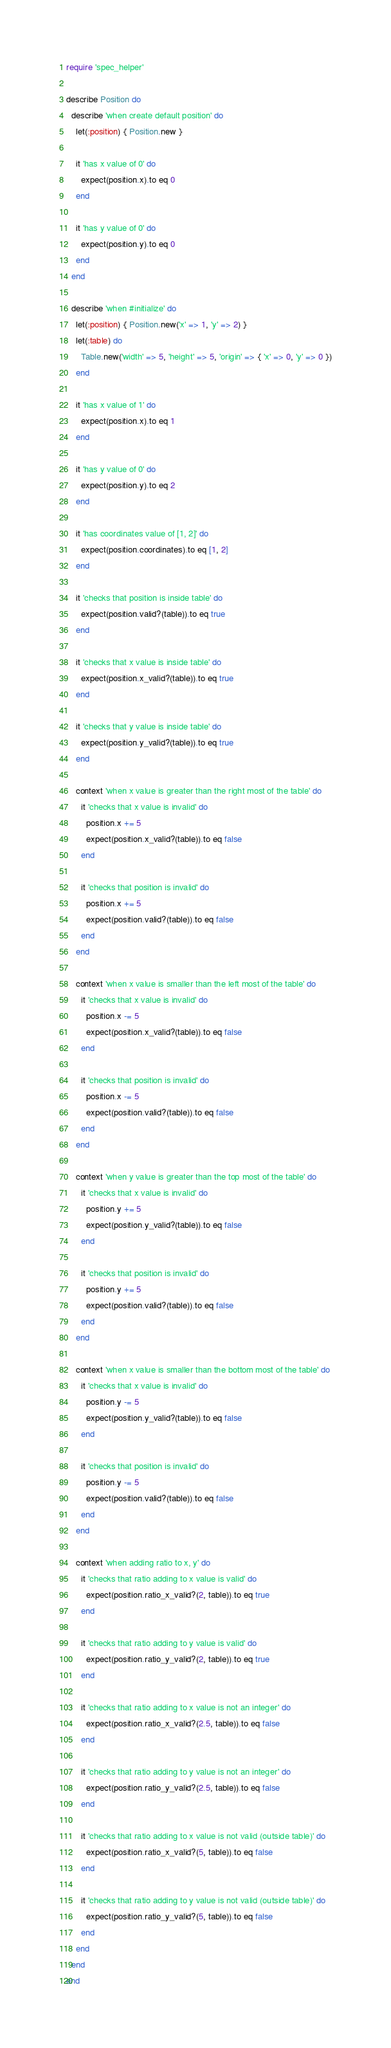<code> <loc_0><loc_0><loc_500><loc_500><_Ruby_>require 'spec_helper'

describe Position do
  describe 'when create default position' do
    let(:position) { Position.new }

    it 'has x value of 0' do
      expect(position.x).to eq 0
    end

    it 'has y value of 0' do
      expect(position.y).to eq 0
    end
  end

  describe 'when #initialize' do
    let(:position) { Position.new('x' => 1, 'y' => 2) }
    let(:table) do
      Table.new('width' => 5, 'height' => 5, 'origin' => { 'x' => 0, 'y' => 0 })
    end

    it 'has x value of 1' do
      expect(position.x).to eq 1
    end

    it 'has y value of 0' do
      expect(position.y).to eq 2
    end

    it 'has coordinates value of [1, 2]' do
      expect(position.coordinates).to eq [1, 2]
    end

    it 'checks that position is inside table' do
      expect(position.valid?(table)).to eq true
    end

    it 'checks that x value is inside table' do
      expect(position.x_valid?(table)).to eq true
    end

    it 'checks that y value is inside table' do
      expect(position.y_valid?(table)).to eq true
    end

    context 'when x value is greater than the right most of the table' do
      it 'checks that x value is invalid' do
        position.x += 5
        expect(position.x_valid?(table)).to eq false
      end

      it 'checks that position is invalid' do
        position.x += 5
        expect(position.valid?(table)).to eq false
      end
    end

    context 'when x value is smaller than the left most of the table' do
      it 'checks that x value is invalid' do
        position.x -= 5
        expect(position.x_valid?(table)).to eq false
      end

      it 'checks that position is invalid' do
        position.x -= 5
        expect(position.valid?(table)).to eq false
      end
    end

    context 'when y value is greater than the top most of the table' do
      it 'checks that x value is invalid' do
        position.y += 5
        expect(position.y_valid?(table)).to eq false
      end

      it 'checks that position is invalid' do
        position.y += 5
        expect(position.valid?(table)).to eq false
      end
    end

    context 'when x value is smaller than the bottom most of the table' do
      it 'checks that x value is invalid' do
        position.y -= 5
        expect(position.y_valid?(table)).to eq false
      end

      it 'checks that position is invalid' do
        position.y -= 5
        expect(position.valid?(table)).to eq false
      end
    end

    context 'when adding ratio to x, y' do
      it 'checks that ratio adding to x value is valid' do
        expect(position.ratio_x_valid?(2, table)).to eq true
      end

      it 'checks that ratio adding to y value is valid' do
        expect(position.ratio_y_valid?(2, table)).to eq true
      end

      it 'checks that ratio adding to x value is not an integer' do
        expect(position.ratio_x_valid?(2.5, table)).to eq false
      end

      it 'checks that ratio adding to y value is not an integer' do
        expect(position.ratio_y_valid?(2.5, table)).to eq false
      end

      it 'checks that ratio adding to x value is not valid (outside table)' do
        expect(position.ratio_x_valid?(5, table)).to eq false
      end

      it 'checks that ratio adding to y value is not valid (outside table)' do
        expect(position.ratio_y_valid?(5, table)).to eq false
      end
    end
  end
end
</code> 